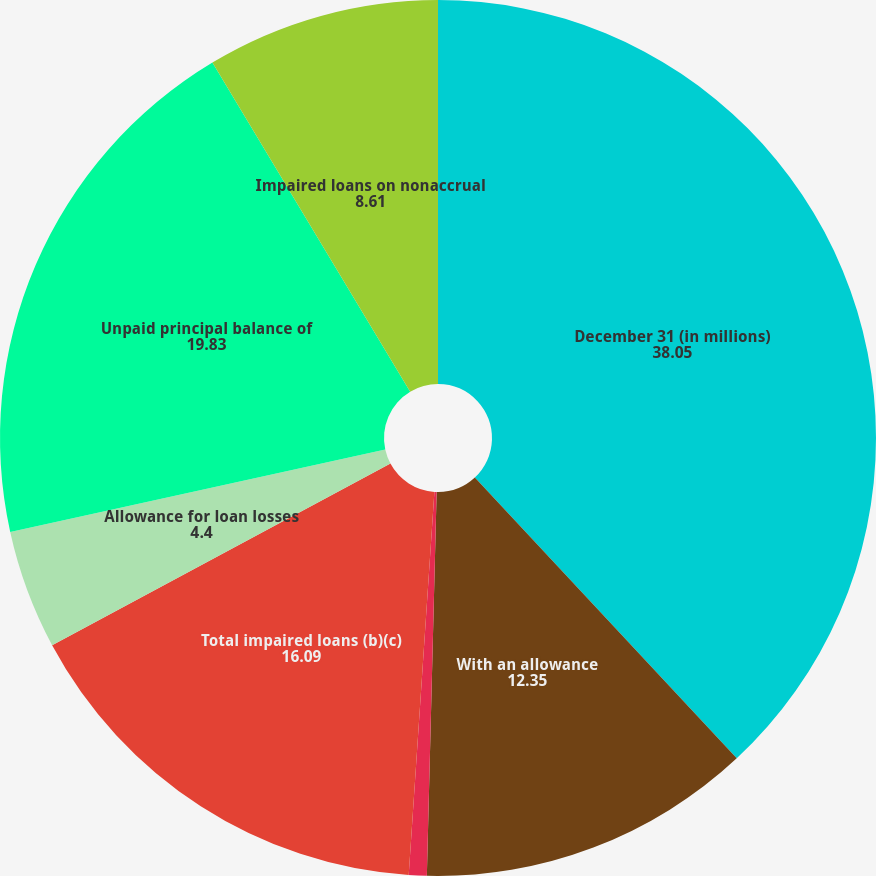Convert chart. <chart><loc_0><loc_0><loc_500><loc_500><pie_chart><fcel>December 31 (in millions)<fcel>With an allowance<fcel>Without an allowance (a)<fcel>Total impaired loans (b)(c)<fcel>Allowance for loan losses<fcel>Unpaid principal balance of<fcel>Impaired loans on nonaccrual<nl><fcel>38.05%<fcel>12.35%<fcel>0.66%<fcel>16.09%<fcel>4.4%<fcel>19.83%<fcel>8.61%<nl></chart> 